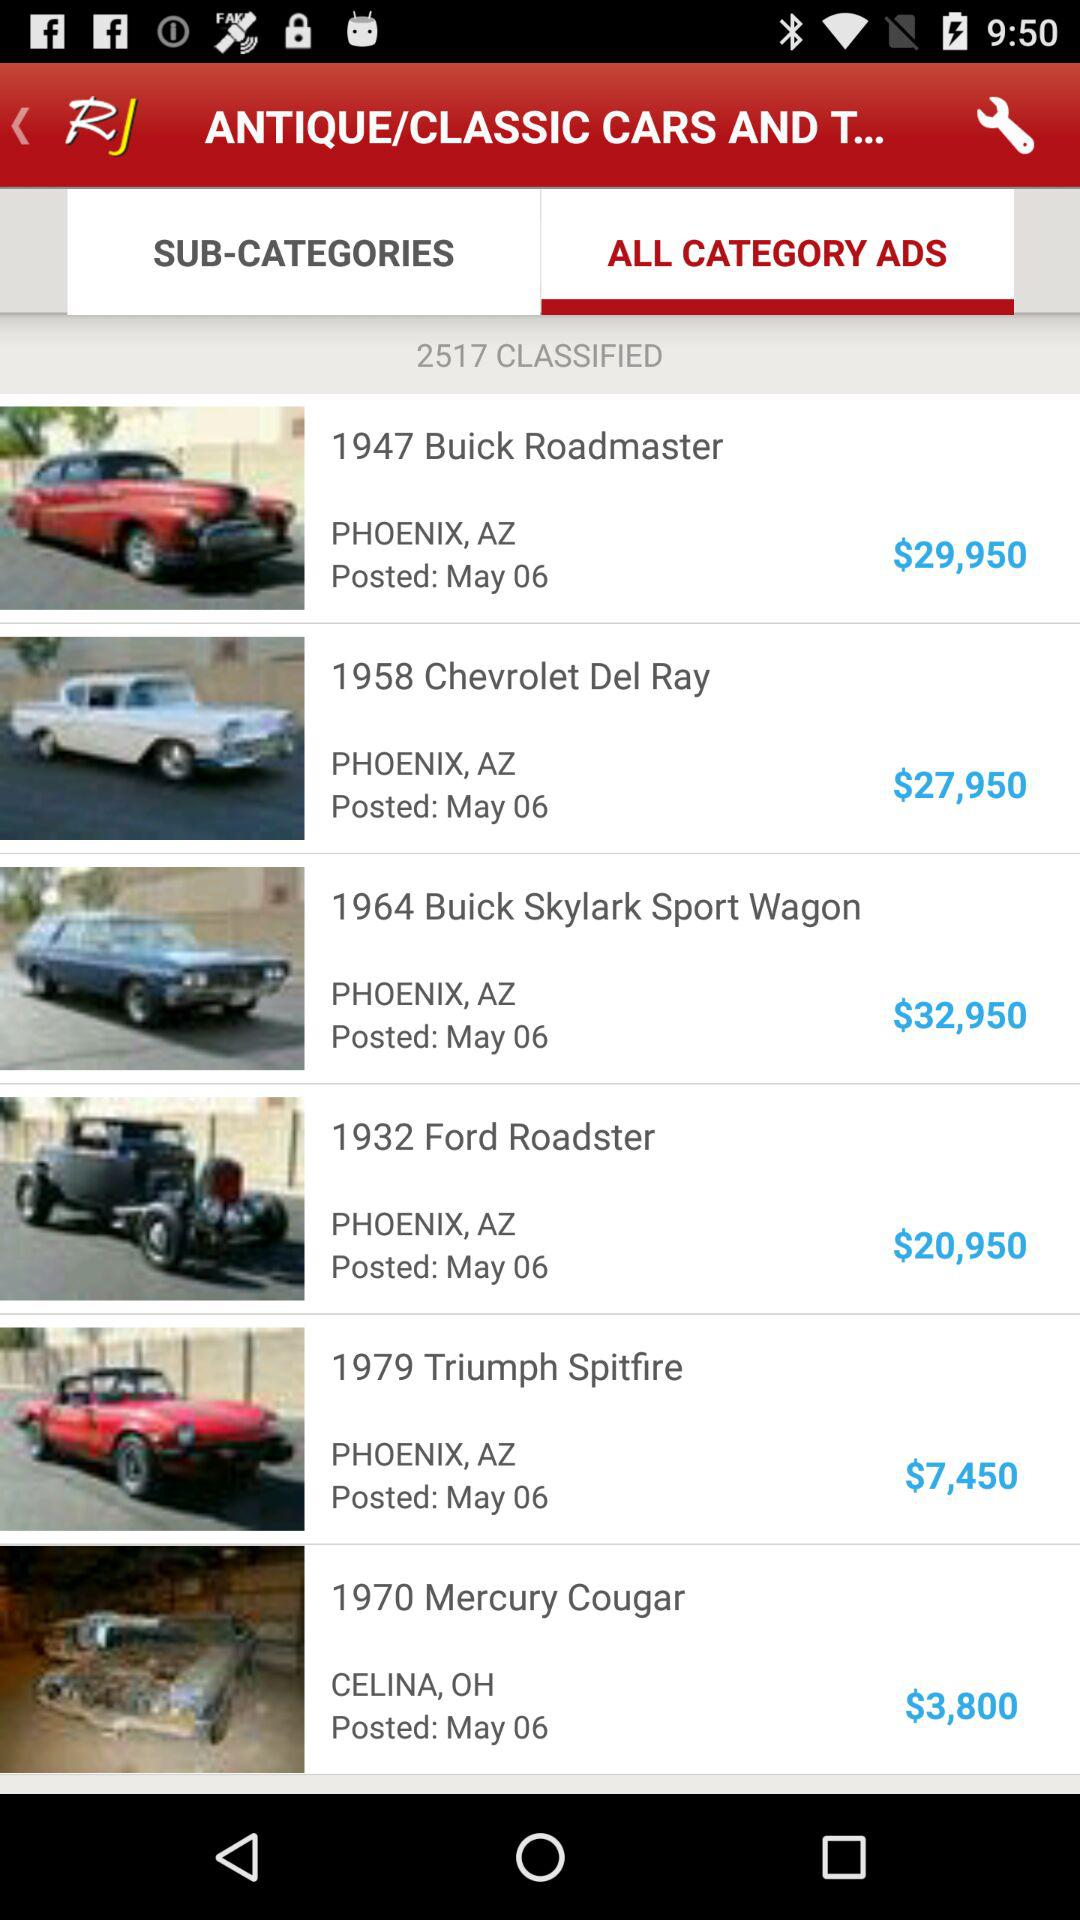What is the price of a "Roadmaster"? The price is $29,950. 